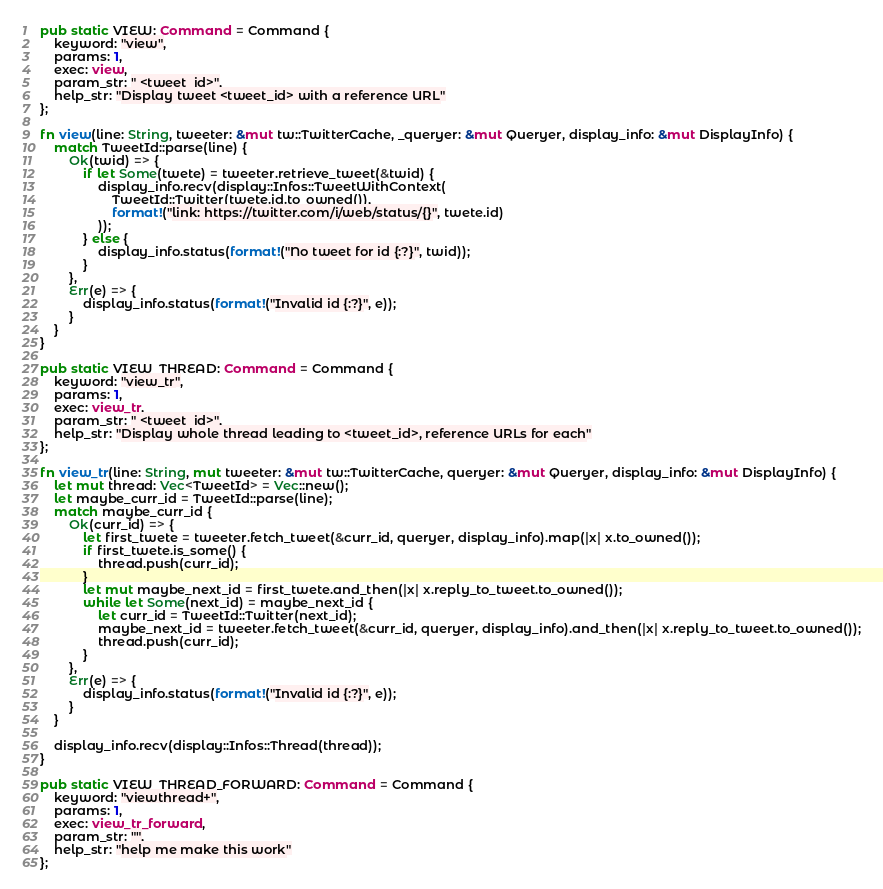Convert code to text. <code><loc_0><loc_0><loc_500><loc_500><_Rust_>
pub static VIEW: Command = Command {
    keyword: "view",
    params: 1,
    exec: view,
    param_str: " <tweet_id>",
    help_str: "Display tweet <tweet_id> with a reference URL"
};

fn view(line: String, tweeter: &mut tw::TwitterCache, _queryer: &mut Queryer, display_info: &mut DisplayInfo) {
    match TweetId::parse(line) {
        Ok(twid) => {
            if let Some(twete) = tweeter.retrieve_tweet(&twid) {
                display_info.recv(display::Infos::TweetWithContext(
                    TweetId::Twitter(twete.id.to_owned()),
                    format!("link: https://twitter.com/i/web/status/{}", twete.id)
                ));
            } else {
                display_info.status(format!("No tweet for id {:?}", twid));
            }
        },
        Err(e) => {
            display_info.status(format!("Invalid id {:?}", e));
        }
    }
}

pub static VIEW_THREAD: Command = Command {
    keyword: "view_tr",
    params: 1,
    exec: view_tr,
    param_str: " <tweet_id>",
    help_str: "Display whole thread leading to <tweet_id>, reference URLs for each"
};

fn view_tr(line: String, mut tweeter: &mut tw::TwitterCache, queryer: &mut Queryer, display_info: &mut DisplayInfo) {
    let mut thread: Vec<TweetId> = Vec::new();
    let maybe_curr_id = TweetId::parse(line);
    match maybe_curr_id {
        Ok(curr_id) => {
            let first_twete = tweeter.fetch_tweet(&curr_id, queryer, display_info).map(|x| x.to_owned());
            if first_twete.is_some() {
                thread.push(curr_id);
            }
            let mut maybe_next_id = first_twete.and_then(|x| x.reply_to_tweet.to_owned());
            while let Some(next_id) = maybe_next_id {
                let curr_id = TweetId::Twitter(next_id);
                maybe_next_id = tweeter.fetch_tweet(&curr_id, queryer, display_info).and_then(|x| x.reply_to_tweet.to_owned());
                thread.push(curr_id);
            }
        },
        Err(e) => {
            display_info.status(format!("Invalid id {:?}", e));
        }
    }

    display_info.recv(display::Infos::Thread(thread));
}

pub static VIEW_THREAD_FORWARD: Command = Command {
    keyword: "viewthread+",
    params: 1,
    exec: view_tr_forward,
    param_str: "",
    help_str: "help me make this work"
};
</code> 